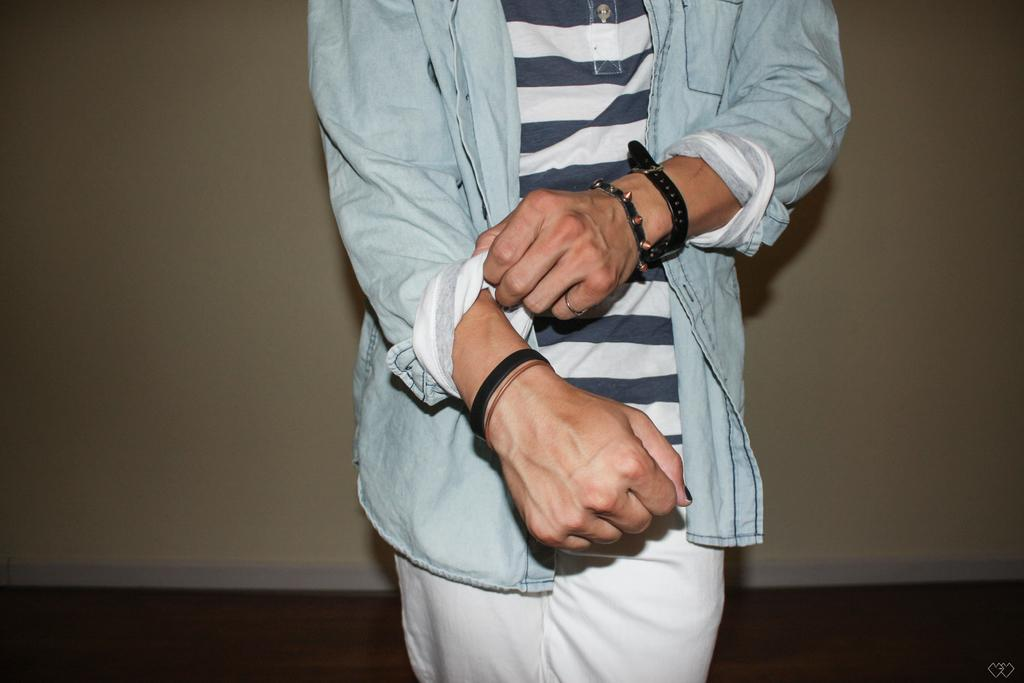What is the main subject in the image? There is a person standing in the image. Can you describe the person's attire? The person is wearing a white and blue color dress. Are there any accessories visible on the person? Yes, the person is wearing bands. What is the color of the wall in the image? The wall in the image is cream-colored. How many cats are sitting on the faucet in the image? There are no cats or faucets present in the image. What is the person saying in the image? The text does not mention any dialogue or mouth movements, so it is not possible to determine what the person might be saying. 